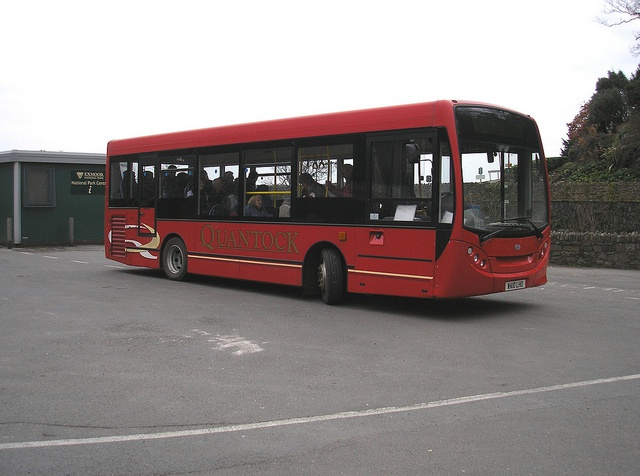Describe the objects in this image and their specific colors. I can see bus in white, black, brown, maroon, and gray tones, people in white, black, gray, and darkgray tones, people in white, black, gray, and lightgray tones, people in white, black, blue, gray, and lightgray tones, and people in white, black, and blue tones in this image. 